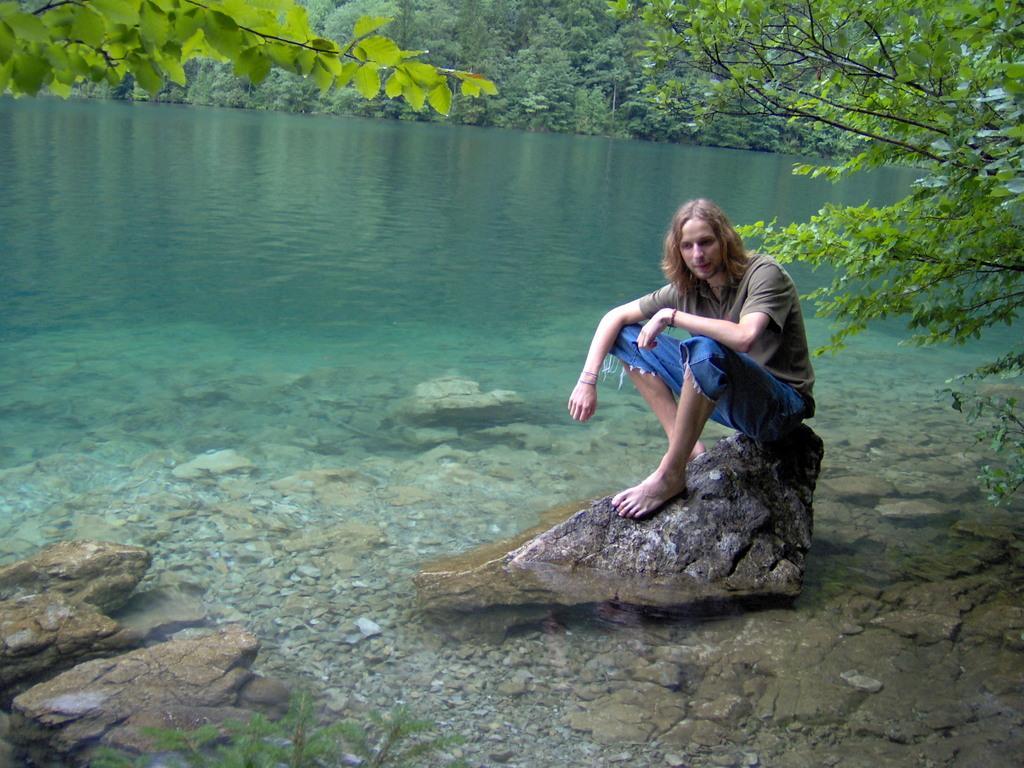How would you summarize this image in a sentence or two? In this image we can see few stones in the water, a person is sitting on the stone and there are few trees in the background. 